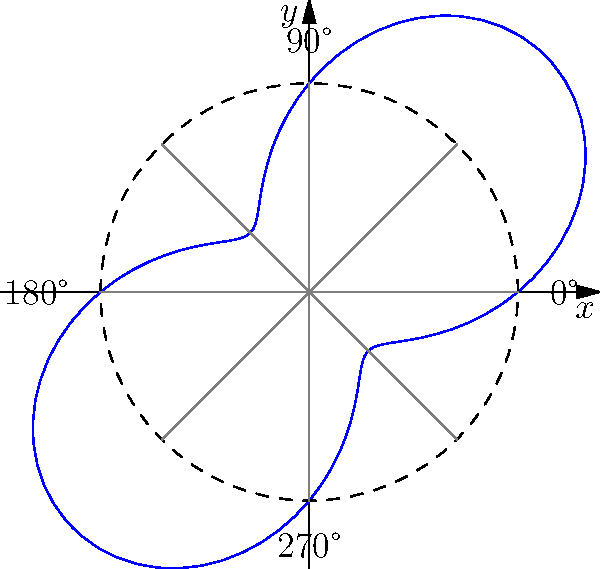In a study of an infectious disease outbreak in a small Texas town, epidemiologists used polar coordinates to represent the spread of the disease from the town center. The radial distance $r$ (in kilometers) from the center is given by the function $r(\theta) = 5 + 3\sin(2\theta)$, where $\theta$ is the angle in radians. What is the maximum distance the infection has spread from the town center, and in which direction(s) does this occur? To find the maximum distance and direction(s) of the infection spread, we need to follow these steps:

1) The function $r(\theta) = 5 + 3\sin(2\theta)$ represents the radial distance from the town center.

2) To find the maximum value of $r$, we need to find where $\sin(2\theta)$ is at its maximum.

3) We know that the maximum value of sine is 1, which occurs when its argument is $\frac{\pi}{2}$ or $\frac{3\pi}{2}$ (and their periodic equivalents).

4) So, we need to solve:
   $2\theta = \frac{\pi}{2}$ or $2\theta = \frac{3\pi}{2}$

5) Solving these equations:
   $\theta = \frac{\pi}{4}$ or $\theta = \frac{3\pi}{4}$

6) These angles correspond to 45° and 135° respectively.

7) The maximum value of $r$ occurs when $\sin(2\theta) = 1$:
   $r_{max} = 5 + 3(1) = 8$ km

8) Due to the symmetry of the sine function, this maximum also occurs at 225° and 315°.

Therefore, the infection has spread a maximum of 8 km from the town center, in four directions: northeast (45°), southeast (135°), southwest (225°), and northwest (315°).
Answer: 8 km; in northeast, southeast, southwest, and northwest directions 